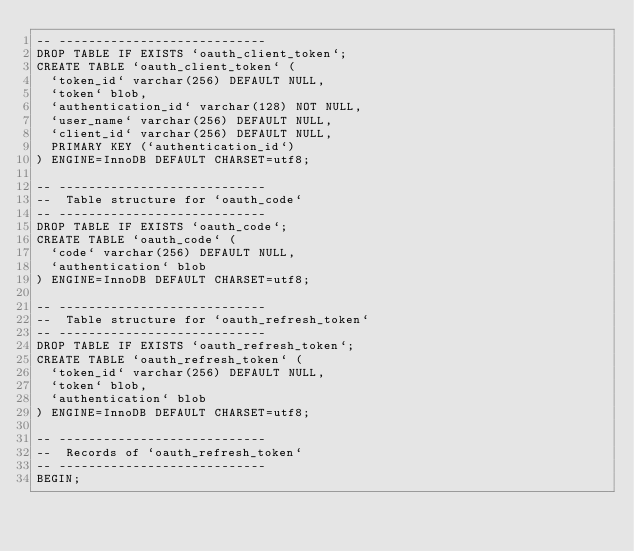Convert code to text. <code><loc_0><loc_0><loc_500><loc_500><_SQL_>-- ----------------------------
DROP TABLE IF EXISTS `oauth_client_token`;
CREATE TABLE `oauth_client_token` (
  `token_id` varchar(256) DEFAULT NULL,
  `token` blob,
  `authentication_id` varchar(128) NOT NULL,
  `user_name` varchar(256) DEFAULT NULL,
  `client_id` varchar(256) DEFAULT NULL,
  PRIMARY KEY (`authentication_id`)
) ENGINE=InnoDB DEFAULT CHARSET=utf8;

-- ----------------------------
--  Table structure for `oauth_code`
-- ----------------------------
DROP TABLE IF EXISTS `oauth_code`;
CREATE TABLE `oauth_code` (
  `code` varchar(256) DEFAULT NULL,
  `authentication` blob
) ENGINE=InnoDB DEFAULT CHARSET=utf8;

-- ----------------------------
--  Table structure for `oauth_refresh_token`
-- ----------------------------
DROP TABLE IF EXISTS `oauth_refresh_token`;
CREATE TABLE `oauth_refresh_token` (
  `token_id` varchar(256) DEFAULT NULL,
  `token` blob,
  `authentication` blob
) ENGINE=InnoDB DEFAULT CHARSET=utf8;

-- ----------------------------
--  Records of `oauth_refresh_token`
-- ----------------------------
BEGIN;</code> 